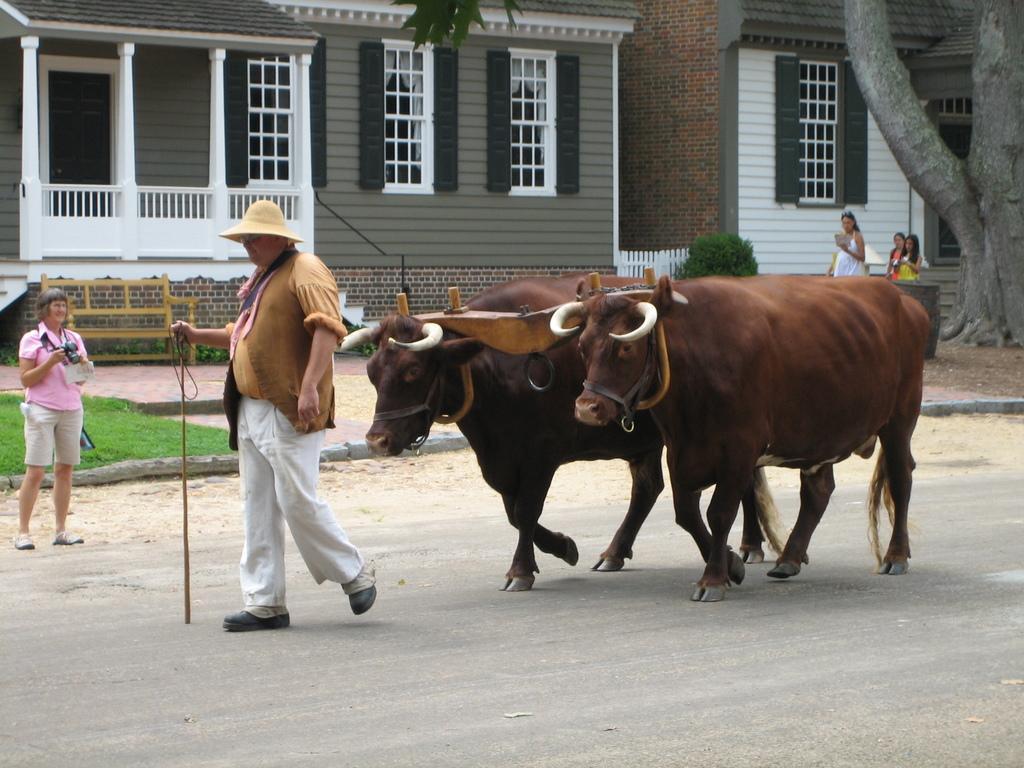Can you describe this image briefly? There is a man walking and holding stick, behind him we can see animals. There is a person standing and holding a camera. In the background we can see grass, people, plants, bench, houses, windows and tree. 